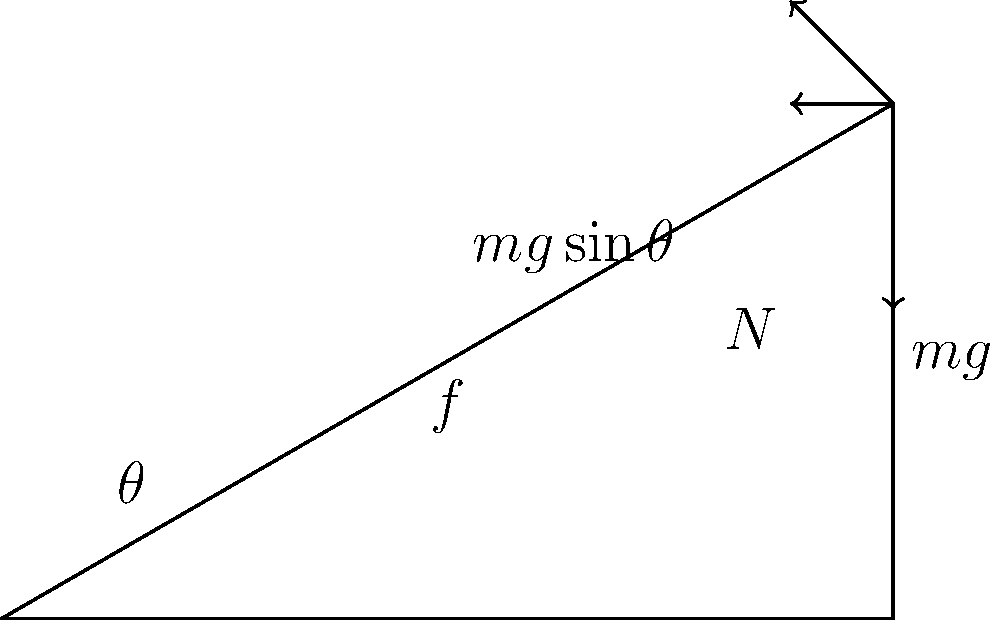As a data scientist applying machine learning techniques to social sciences research, you're developing a model to predict human behavior in various physical scenarios. To validate your model, you need to accurately analyze the forces acting on an object on an inclined plane. Consider a block of mass $m = 2$ kg on a frictionless inclined plane at an angle $\theta = 30°$ to the horizontal. What is the magnitude of the force parallel to the inclined plane that causes the block to accelerate down the slope? Express your answer in terms of $g = 9.8$ m/s². To solve this problem, we'll follow these steps:

1. Identify the forces acting on the block:
   - Weight ($mg$) acting downward
   - Normal force ($N$) perpendicular to the inclined plane
   - No friction force (frictionless surface)

2. Resolve the weight vector into components:
   - Parallel to the plane: $mg\sin\theta$
   - Perpendicular to the plane: $mg\cos\theta$

3. The force causing acceleration down the slope is the component of weight parallel to the plane:
   $F = mg\sin\theta$

4. Substitute the given values:
   $m = 2$ kg
   $g = 9.8$ m/s²
   $\theta = 30°$

5. Calculate:
   $F = 2 \cdot 9.8 \cdot \sin(30°)$
   $F = 19.6 \cdot 0.5$
   $F = 9.8$ N

The magnitude of the force parallel to the inclined plane is 9.8 N, which can be expressed as $mg\sin\theta$ or $mg \cdot 0.5$.
Answer: $mg\sin\theta$ or $9.8$ N 